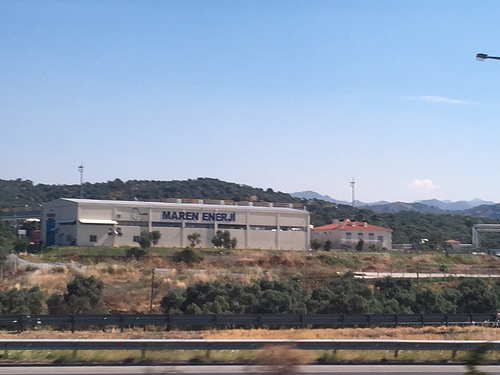<image>
Can you confirm if the sky is behind the mountain? Yes. From this viewpoint, the sky is positioned behind the mountain, with the mountain partially or fully occluding the sky. 